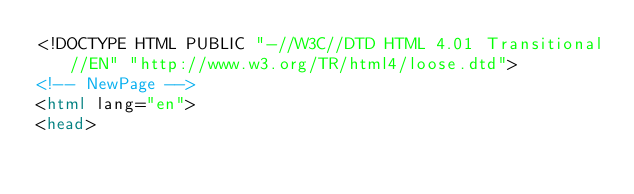<code> <loc_0><loc_0><loc_500><loc_500><_HTML_><!DOCTYPE HTML PUBLIC "-//W3C//DTD HTML 4.01 Transitional//EN" "http://www.w3.org/TR/html4/loose.dtd">
<!-- NewPage -->
<html lang="en">
<head></code> 